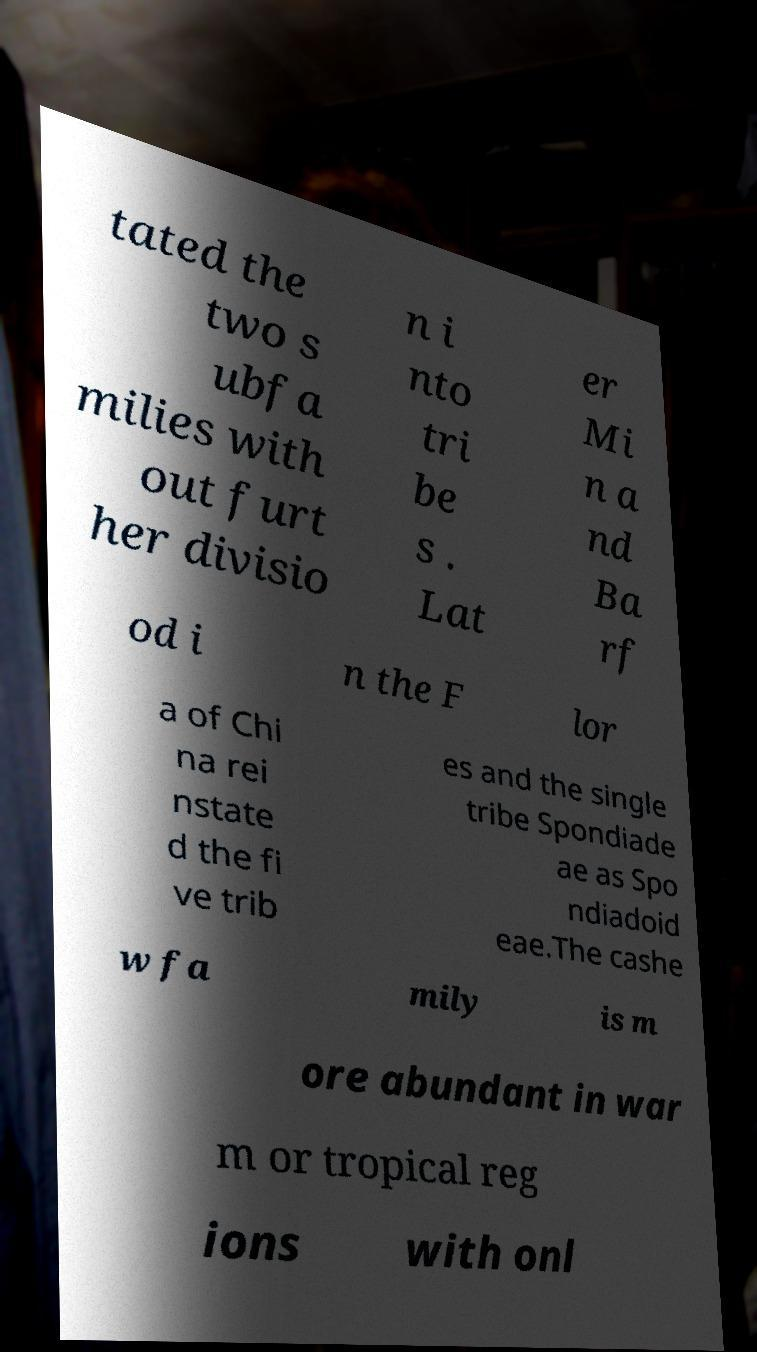What messages or text are displayed in this image? I need them in a readable, typed format. tated the two s ubfa milies with out furt her divisio n i nto tri be s . Lat er Mi n a nd Ba rf od i n the F lor a of Chi na rei nstate d the fi ve trib es and the single tribe Spondiade ae as Spo ndiadoid eae.The cashe w fa mily is m ore abundant in war m or tropical reg ions with onl 